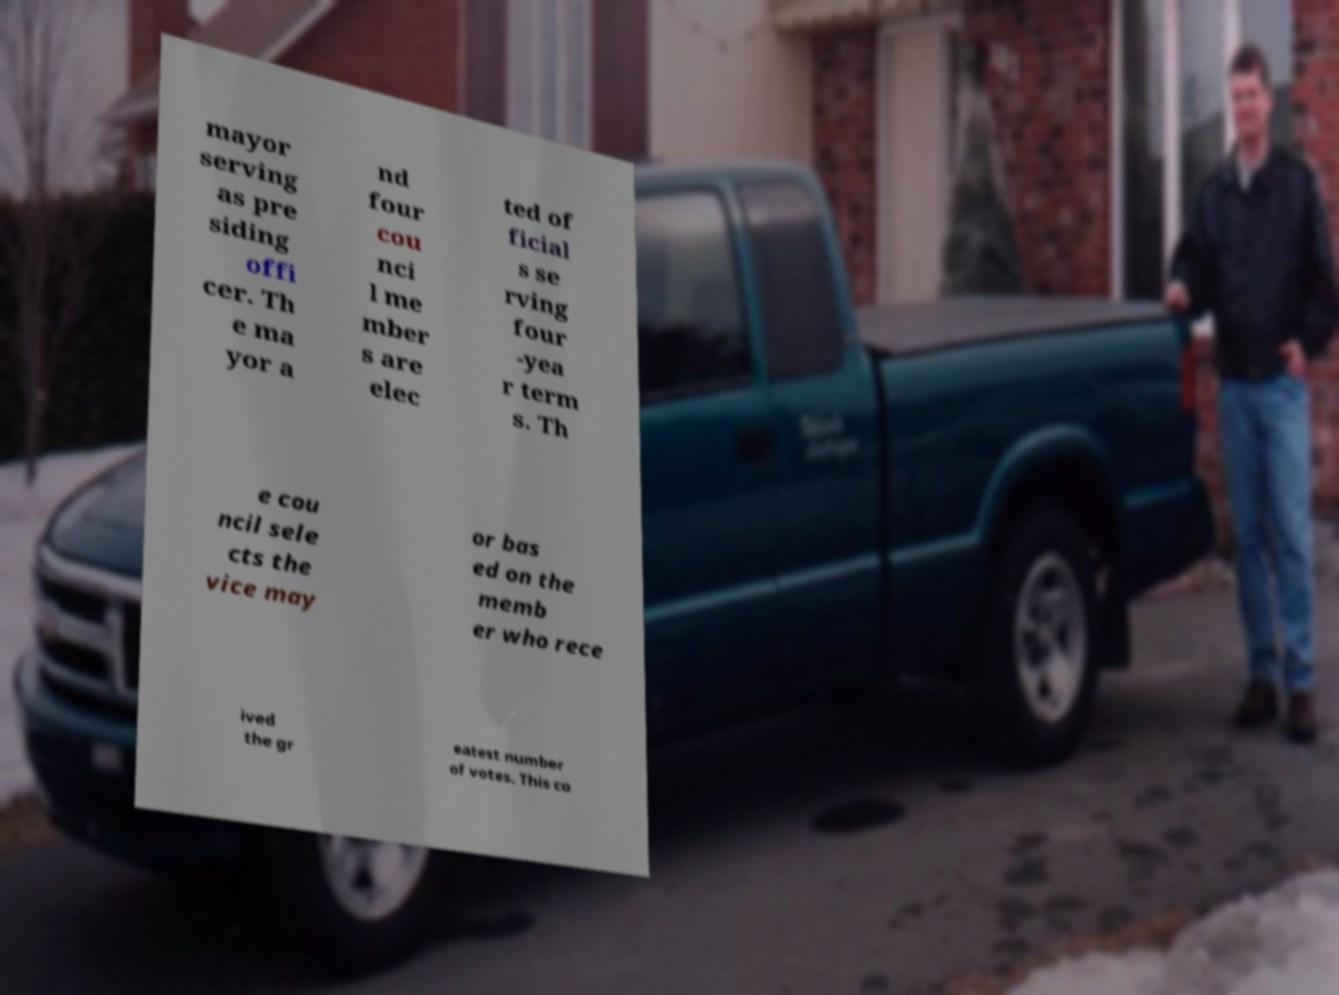What messages or text are displayed in this image? I need them in a readable, typed format. mayor serving as pre siding offi cer. Th e ma yor a nd four cou nci l me mber s are elec ted of ficial s se rving four -yea r term s. Th e cou ncil sele cts the vice may or bas ed on the memb er who rece ived the gr eatest number of votes. This co 